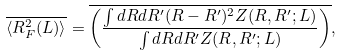<formula> <loc_0><loc_0><loc_500><loc_500>\overline { \langle { R } _ { F } ^ { 2 } ( L ) \rangle } = \overline { \left ( \frac { \int d { R } d { R ^ { \prime } } ( { R } - { R ^ { \prime } } ) ^ { 2 } Z ( { R } , { R ^ { \prime } } ; L ) } { \int d { R } d { R ^ { \prime } } Z ( { R } , { R ^ { \prime } } ; L ) } \right ) } ,</formula> 